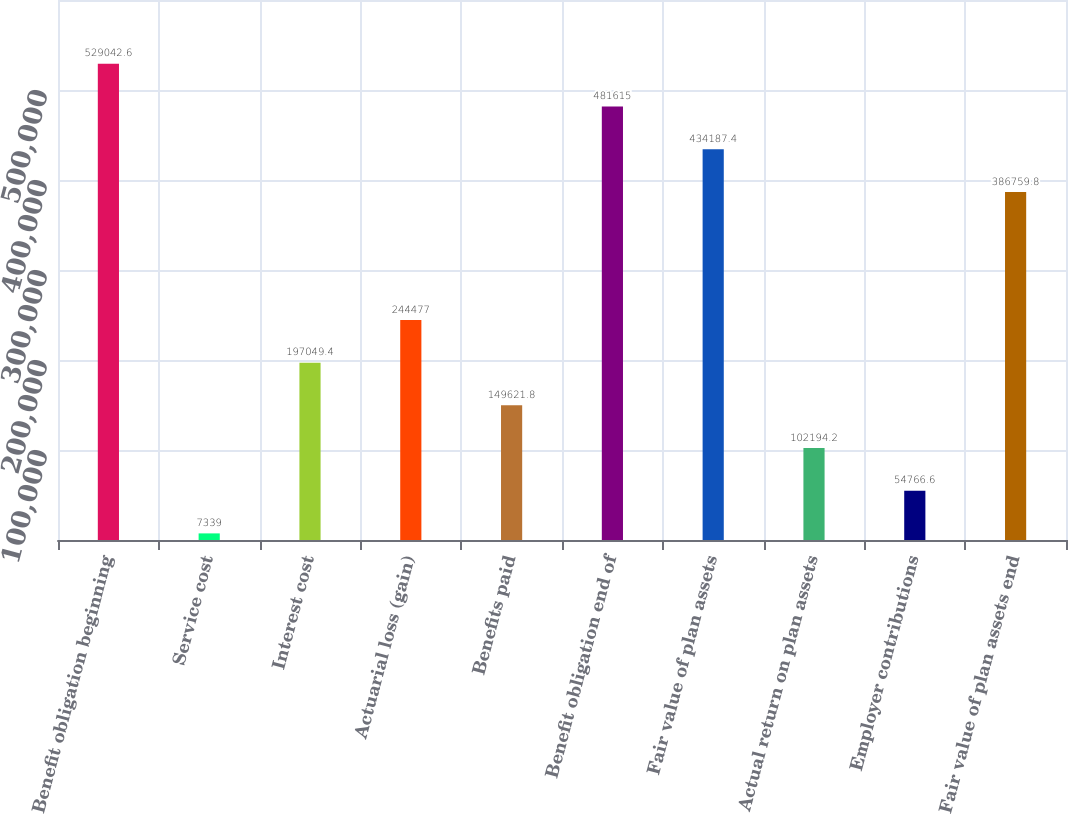<chart> <loc_0><loc_0><loc_500><loc_500><bar_chart><fcel>Benefit obligation beginning<fcel>Service cost<fcel>Interest cost<fcel>Actuarial loss (gain)<fcel>Benefits paid<fcel>Benefit obligation end of<fcel>Fair value of plan assets<fcel>Actual return on plan assets<fcel>Employer contributions<fcel>Fair value of plan assets end<nl><fcel>529043<fcel>7339<fcel>197049<fcel>244477<fcel>149622<fcel>481615<fcel>434187<fcel>102194<fcel>54766.6<fcel>386760<nl></chart> 